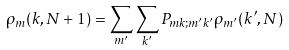Convert formula to latex. <formula><loc_0><loc_0><loc_500><loc_500>\rho _ { m } ( k , N + 1 ) = \sum _ { m ^ { \prime } } \sum _ { k ^ { \prime } } P _ { m k ; m ^ { \prime } k ^ { \prime } } \rho _ { m ^ { \prime } } ( k ^ { \prime } , N )</formula> 